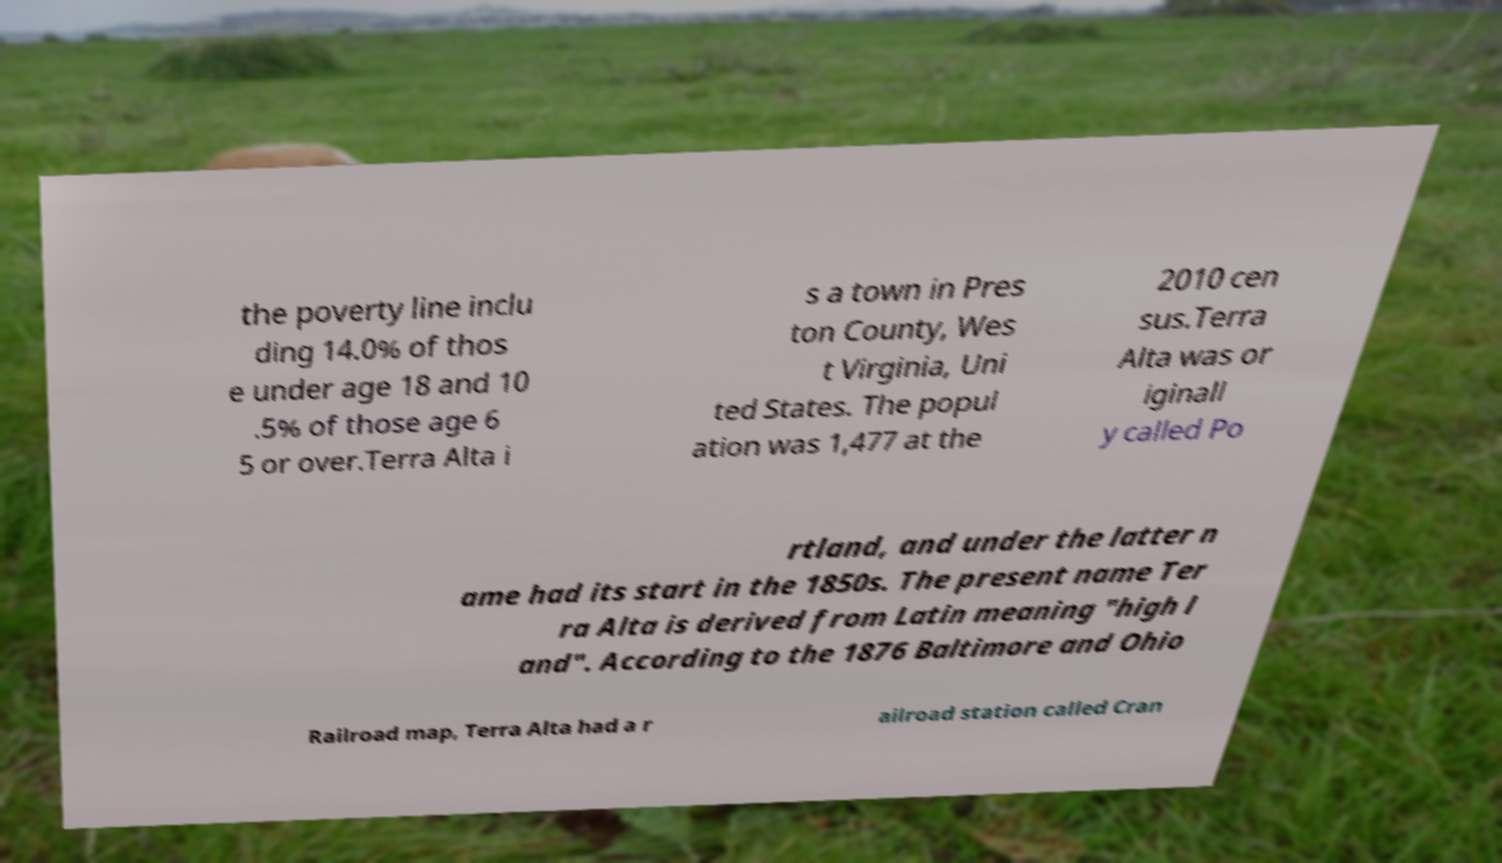Can you accurately transcribe the text from the provided image for me? the poverty line inclu ding 14.0% of thos e under age 18 and 10 .5% of those age 6 5 or over.Terra Alta i s a town in Pres ton County, Wes t Virginia, Uni ted States. The popul ation was 1,477 at the 2010 cen sus.Terra Alta was or iginall y called Po rtland, and under the latter n ame had its start in the 1850s. The present name Ter ra Alta is derived from Latin meaning "high l and". According to the 1876 Baltimore and Ohio Railroad map, Terra Alta had a r ailroad station called Cran 